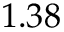Convert formula to latex. <formula><loc_0><loc_0><loc_500><loc_500>1 . 3 8</formula> 